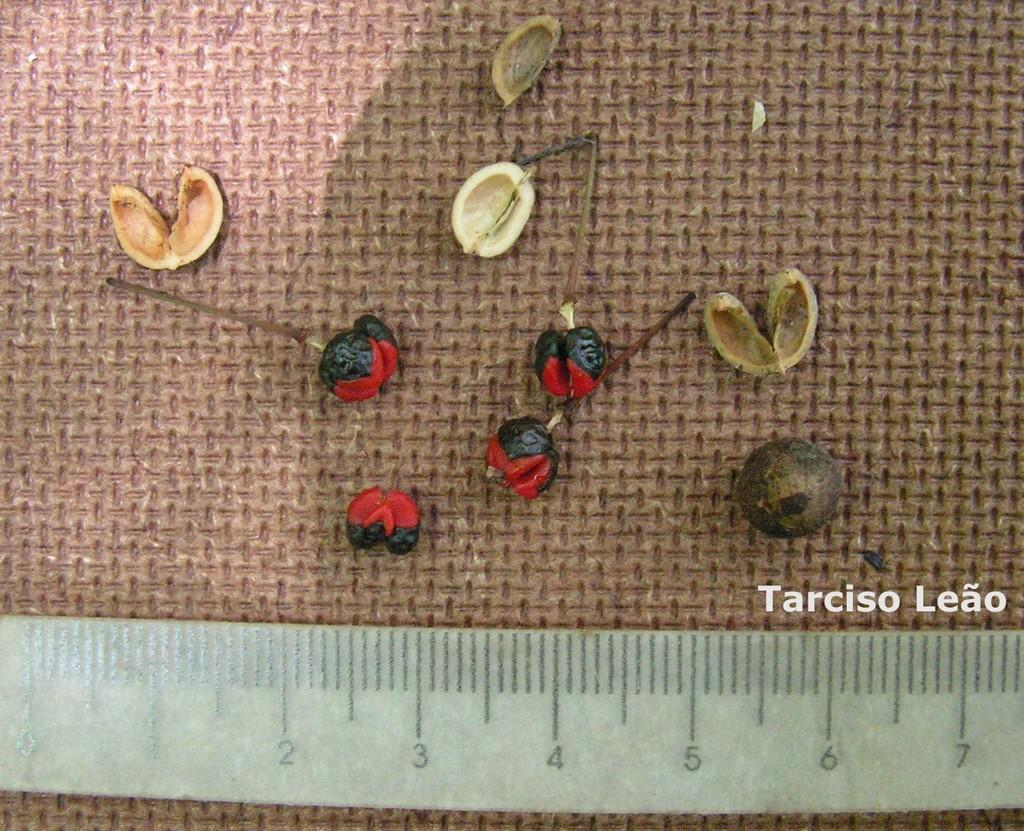Provide a one-sentence caption for the provided image. Items used by Tarciso Leao for pins and nuts. 